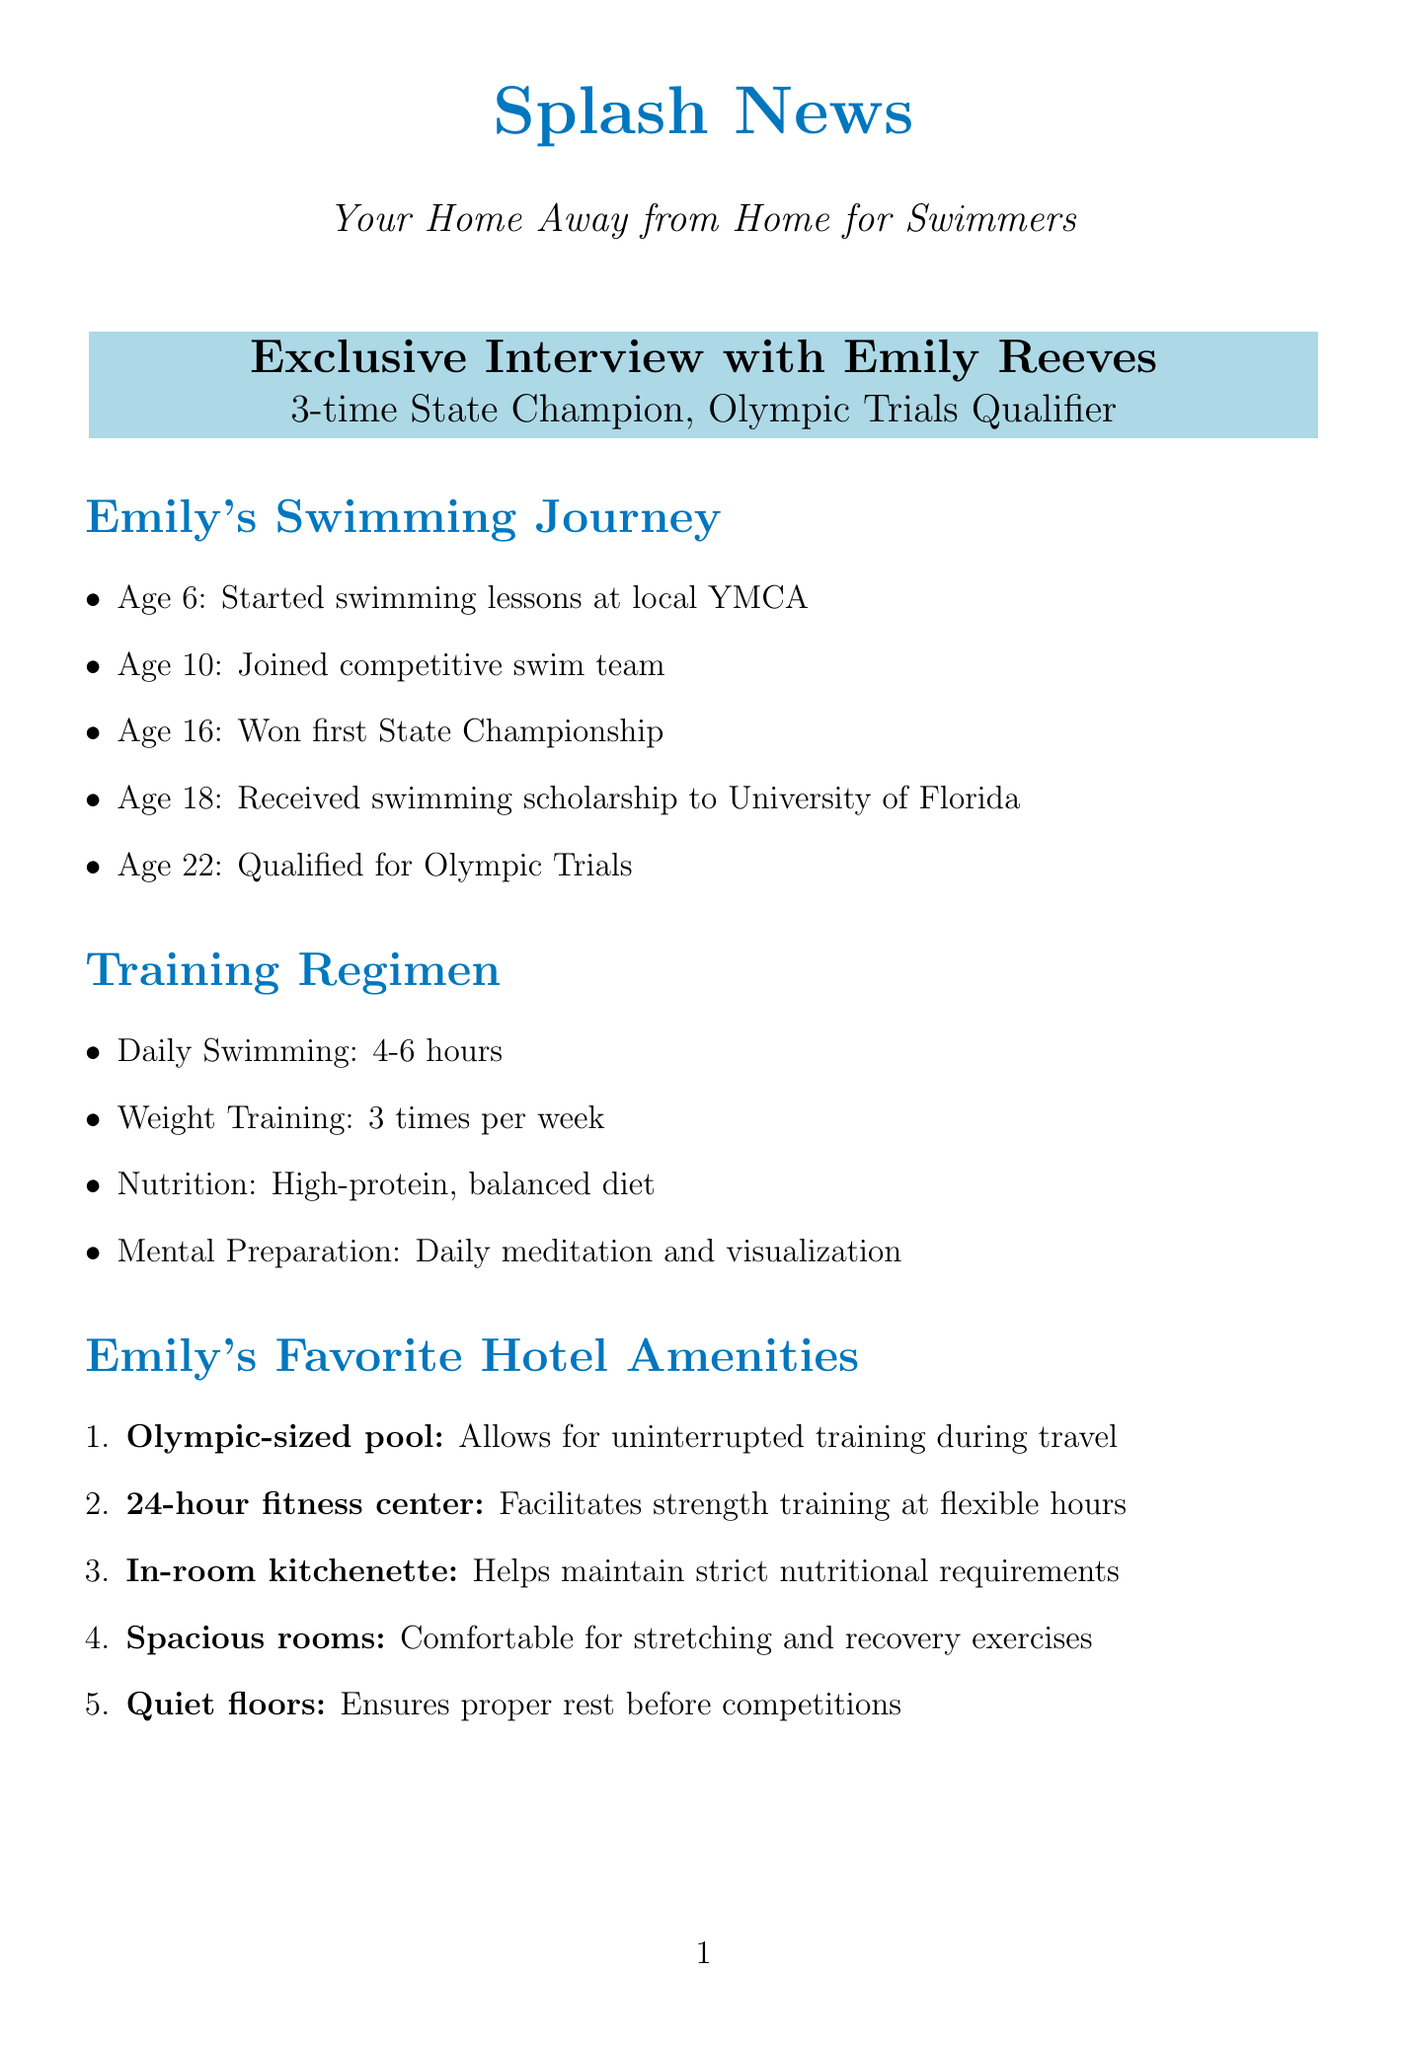What are Emily's main achievements? The document lists her achievements as a 3-time State Swimming Champion, 2-time National Finalist, and Olympic Trials Qualifier.
Answer: 3-time State Champion, 2-time National Finalist, Olympic Trials Qualifier At what age did Emily start swimming lessons? The document states that Emily started swimming lessons at the age of 6.
Answer: 6 What is Emily's daily swimming duration? It is mentioned in the document that Emily swims for about 4-6 hours daily.
Answer: 4-6 hours Which hotel amenity helps maintain strict nutritional requirements? The document indicates that an in-room kitchenette helps maintain strict nutritional requirements.
Answer: In-room kitchenette What special accommodation is provided for pre-competition mornings? It is noted that there are early breakfast options for pre-competition mornings.
Answer: Early breakfast options What advice does Emily give regarding swimming technique? The document states that she emphasizes focusing on technique before speed.
Answer: Focus on technique before speed Where will the USA Swimming National Championships be held? According to the document, the championships will take place in Indianapolis, Indiana.
Answer: Indianapolis, Indiana How many times does Emily engage in weight training each week? The document specifies that Emily performs weight training three times per week.
Answer: 3 times per week 